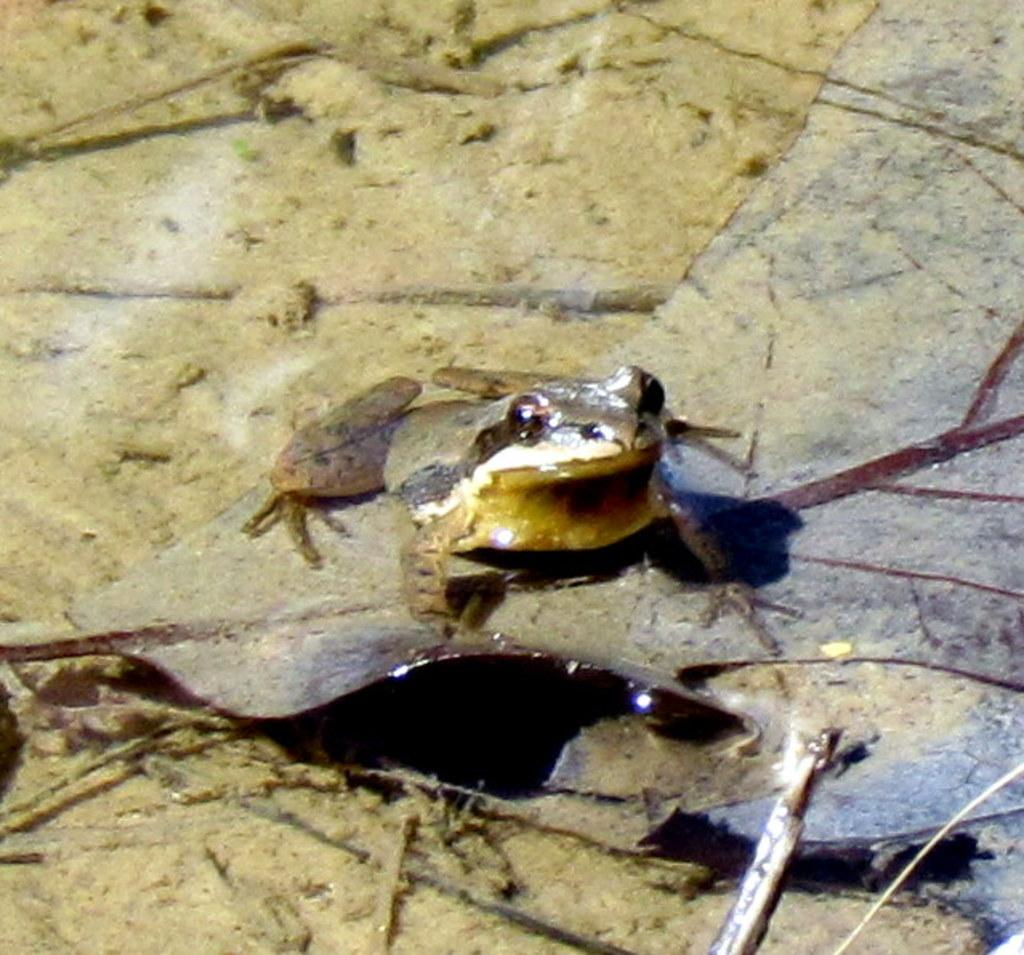What animal is on the ground in the image? There is a frog on the ground in the image. What else can be seen in the image besides the frog? There are sticks visible in the image. What type of writing can be seen on the frog's back in the image? There is no writing visible on the frog's back in the image. Can you see a hen in the image? There is no hen present in the image. 